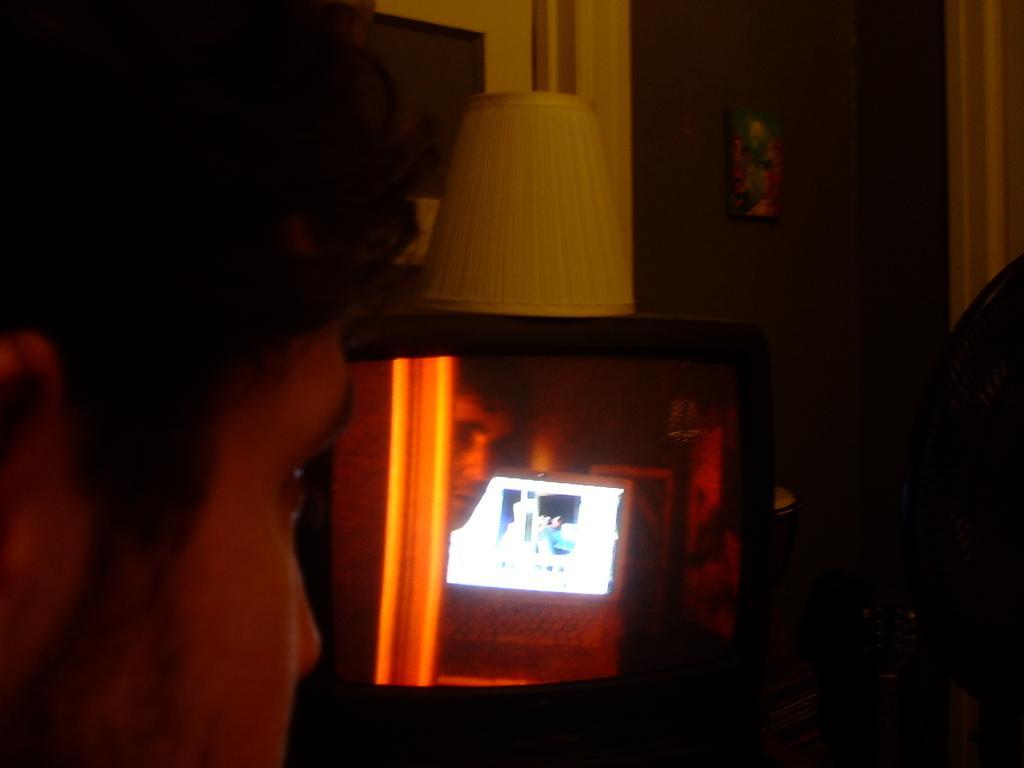How would you summarize this image in a sentence or two? In this image I can see a person head, laptop on the screen. I can see the white color object on the television. Back I can see few objects. In front I can see the person face. The image is dark. 